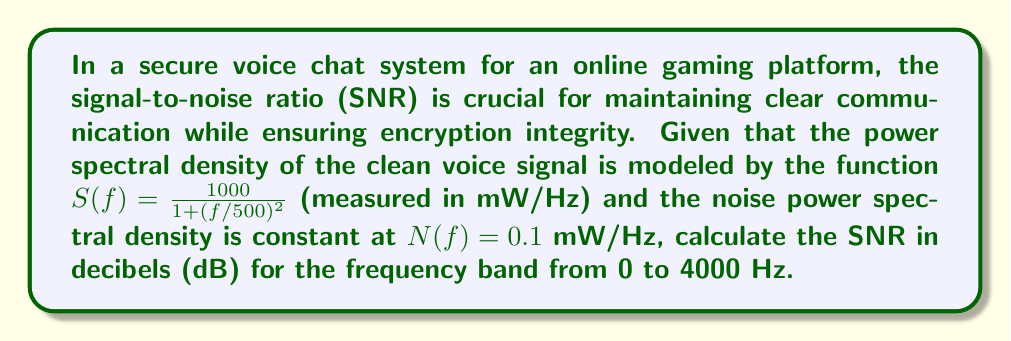Can you solve this math problem? To solve this problem, we need to follow these steps:

1) The SNR is defined as the ratio of signal power to noise power. In the frequency domain, we can calculate this using the power spectral densities:

   $$ \text{SNR} = \frac{\text{Signal Power}}{\text{Noise Power}} = \frac{\int_0^{4000} S(f) df}{\int_0^{4000} N(f) df} $$

2) Let's calculate the signal power first:

   $$ \int_0^{4000} S(f) df = \int_0^{4000} \frac{1000}{1 + (f/500)^2} df $$

   This integral can be solved using the arctangent function:

   $$ = 1000 \cdot 500 \cdot [\arctan(f/500)]_0^{4000} $$
   $$ = 500000 \cdot [\arctan(8) - \arctan(0)] $$
   $$ = 500000 \cdot 1.4464 = 723200 \text{ mW} $$

3) Now for the noise power:

   $$ \int_0^{4000} N(f) df = 0.1 \cdot 4000 = 400 \text{ mW} $$

4) The SNR is thus:

   $$ \text{SNR} = \frac{723200}{400} = 1808 $$

5) To convert to decibels, we use the formula:

   $$ \text{SNR}_{\text{dB}} = 10 \log_{10}(\text{SNR}) $$
   $$ = 10 \log_{10}(1808) = 32.57 \text{ dB} $$
Answer: The signal-to-noise ratio (SNR) for the given secure voice chat system in the frequency band from 0 to 4000 Hz is approximately 32.57 dB. 